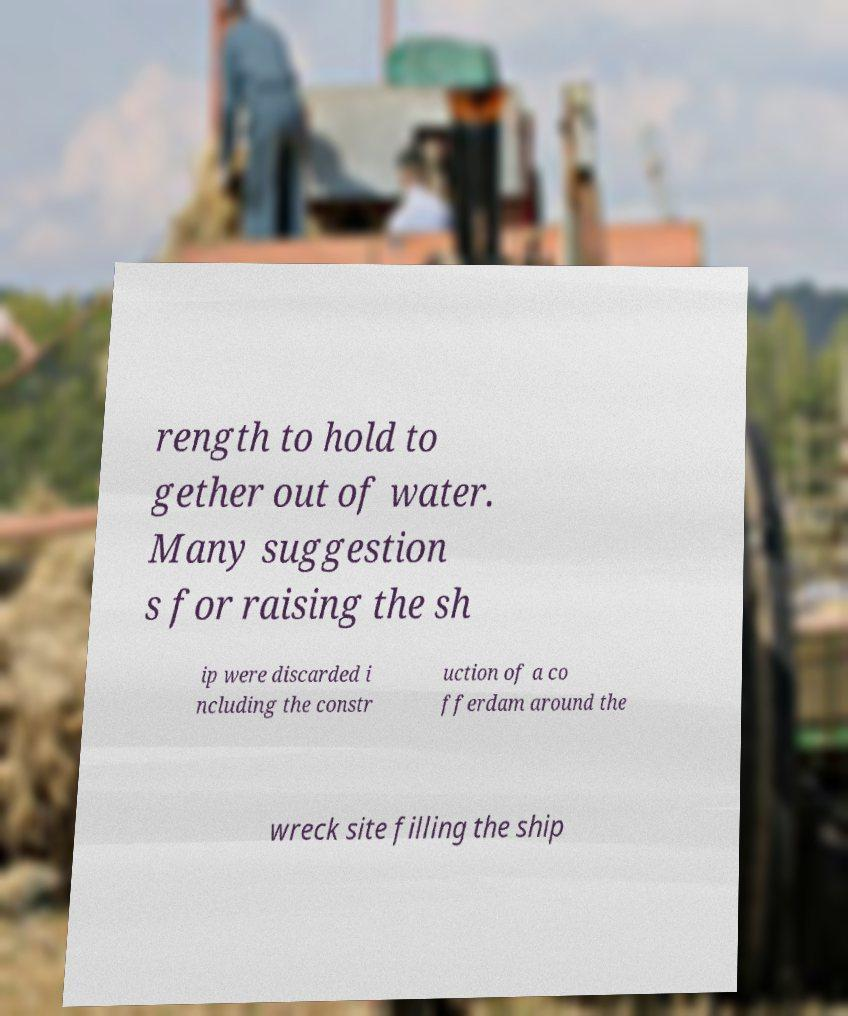Could you assist in decoding the text presented in this image and type it out clearly? rength to hold to gether out of water. Many suggestion s for raising the sh ip were discarded i ncluding the constr uction of a co fferdam around the wreck site filling the ship 